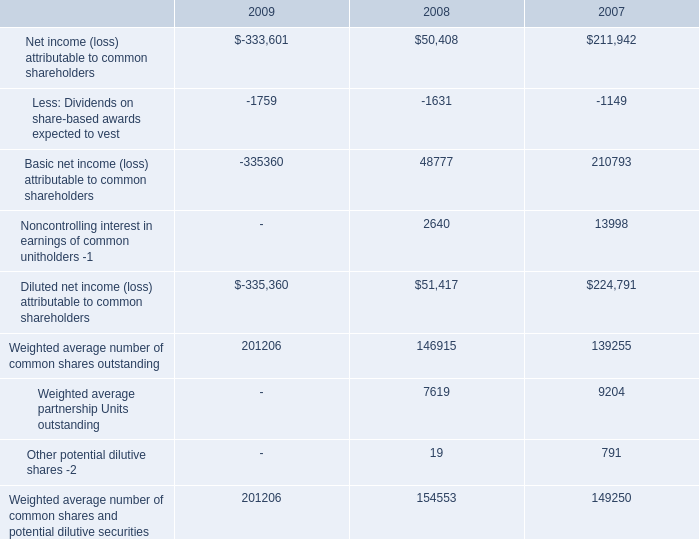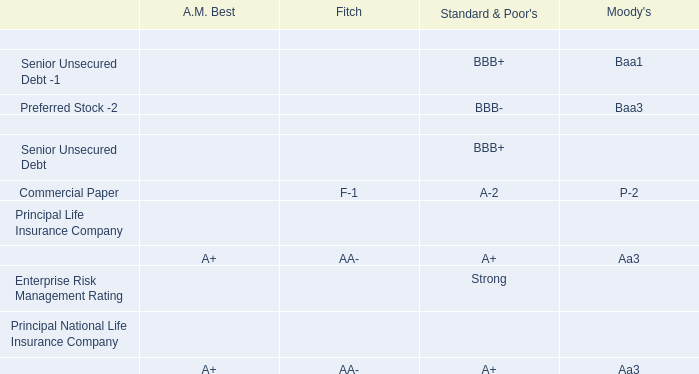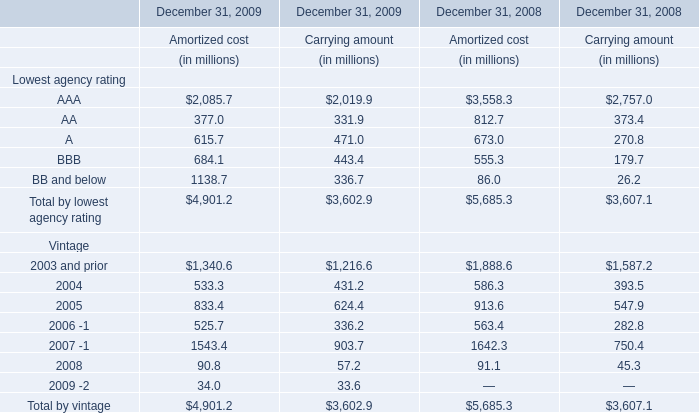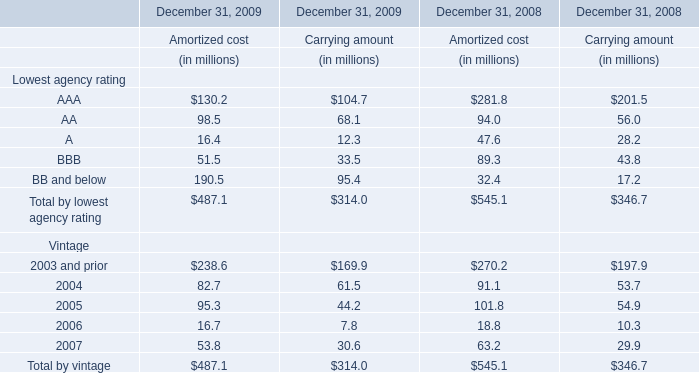what was the percent of the decline in net income ( loss ) attributable to common shareholders from 2007 to 2008 
Computations: ((50408 - 211942) / 211942)
Answer: -0.76216. 